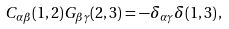<formula> <loc_0><loc_0><loc_500><loc_500>C _ { \alpha \beta } ( 1 , 2 ) G _ { \beta \gamma } ( 2 , 3 ) = - \delta _ { \alpha \gamma } \delta ( 1 , 3 ) \, ,</formula> 